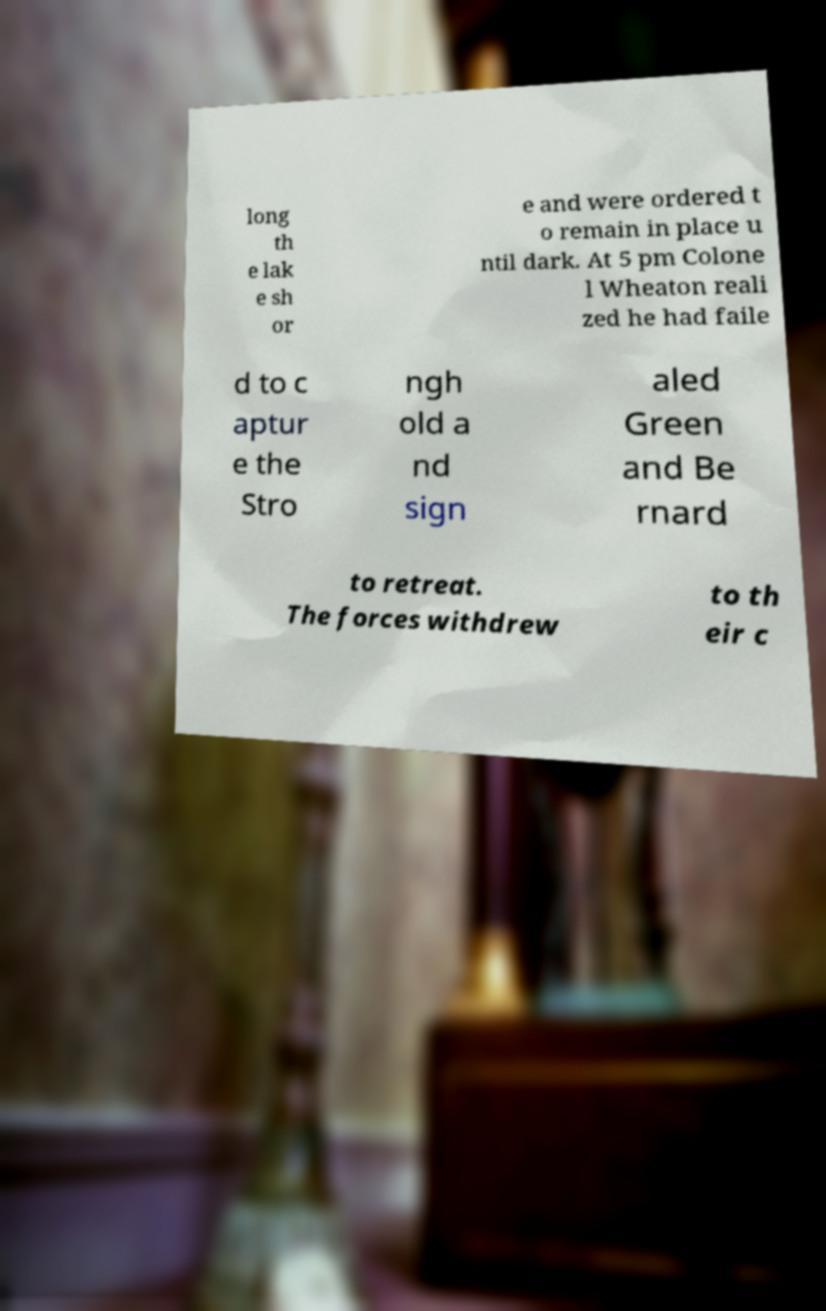Please read and relay the text visible in this image. What does it say? long th e lak e sh or e and were ordered t o remain in place u ntil dark. At 5 pm Colone l Wheaton reali zed he had faile d to c aptur e the Stro ngh old a nd sign aled Green and Be rnard to retreat. The forces withdrew to th eir c 